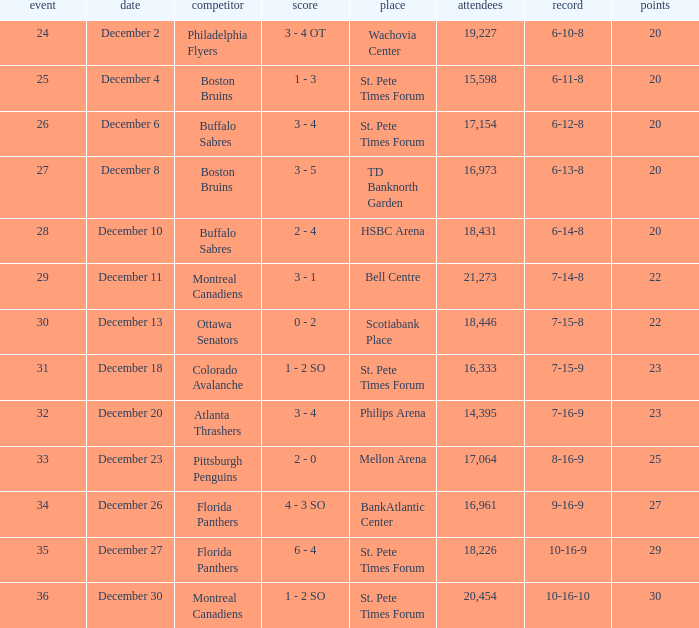What game has a 6-12-8 record? 26.0. 